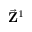Convert formula to latex. <formula><loc_0><loc_0><loc_500><loc_500>\vec { Z } ^ { 1 }</formula> 